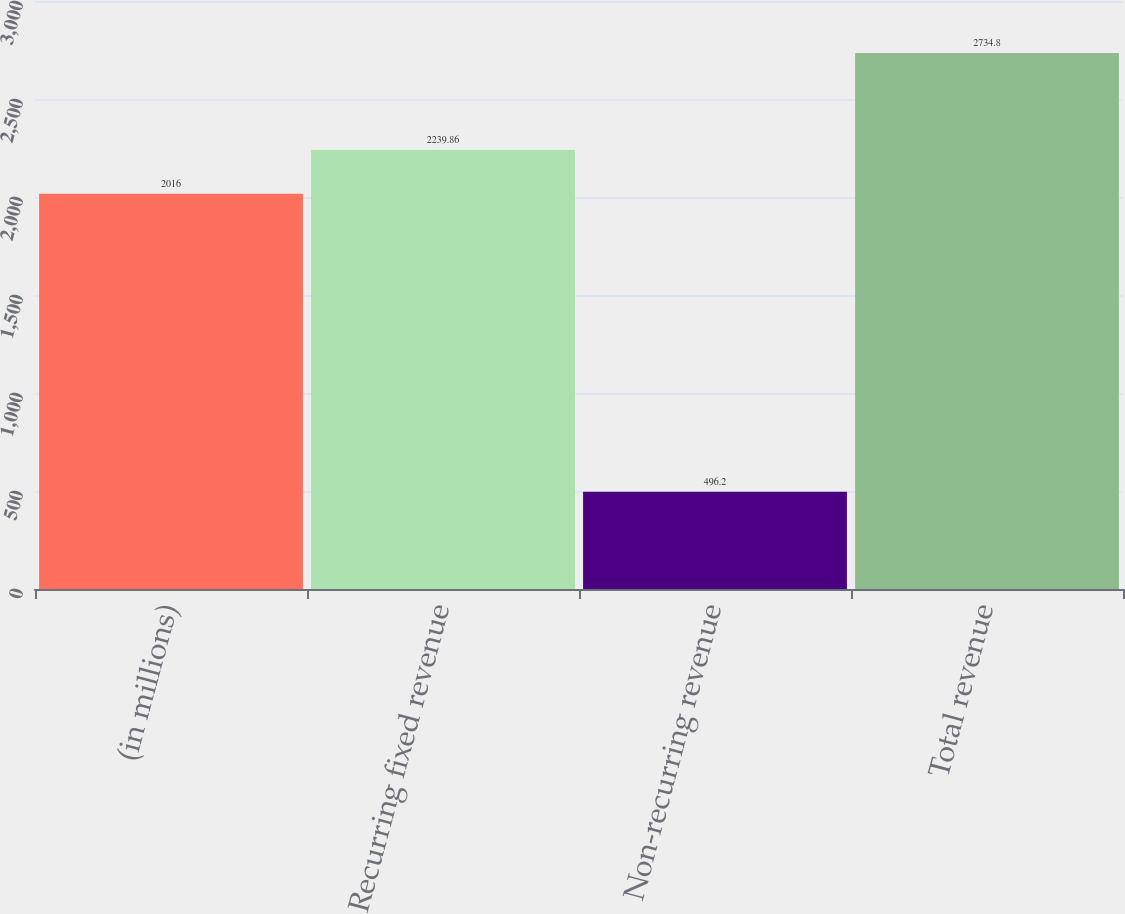Convert chart. <chart><loc_0><loc_0><loc_500><loc_500><bar_chart><fcel>(in millions)<fcel>Recurring fixed revenue<fcel>Non-recurring revenue<fcel>Total revenue<nl><fcel>2016<fcel>2239.86<fcel>496.2<fcel>2734.8<nl></chart> 